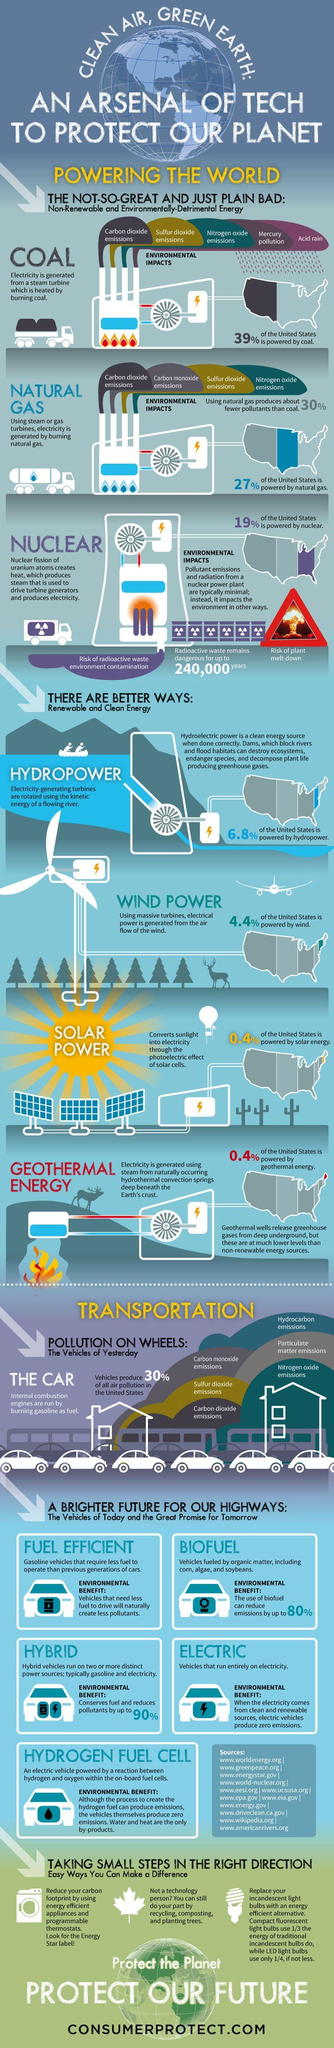Highlight a few significant elements in this photo. The United States uses 85% of its energy sources that are non-renewable. According to recent data, only 0.4% of the United States uses solar power and geothermal energy to produce electricity. The region of the United States that is still powered primarily by coal is the West. Nonrenewable sources of energy, including coal, natural gas, and nuclear power, are finite resources that are expected to be depleted in the near future. In the United States, approximately 12% of the total energy consumption comes from renewable sources of energy. 